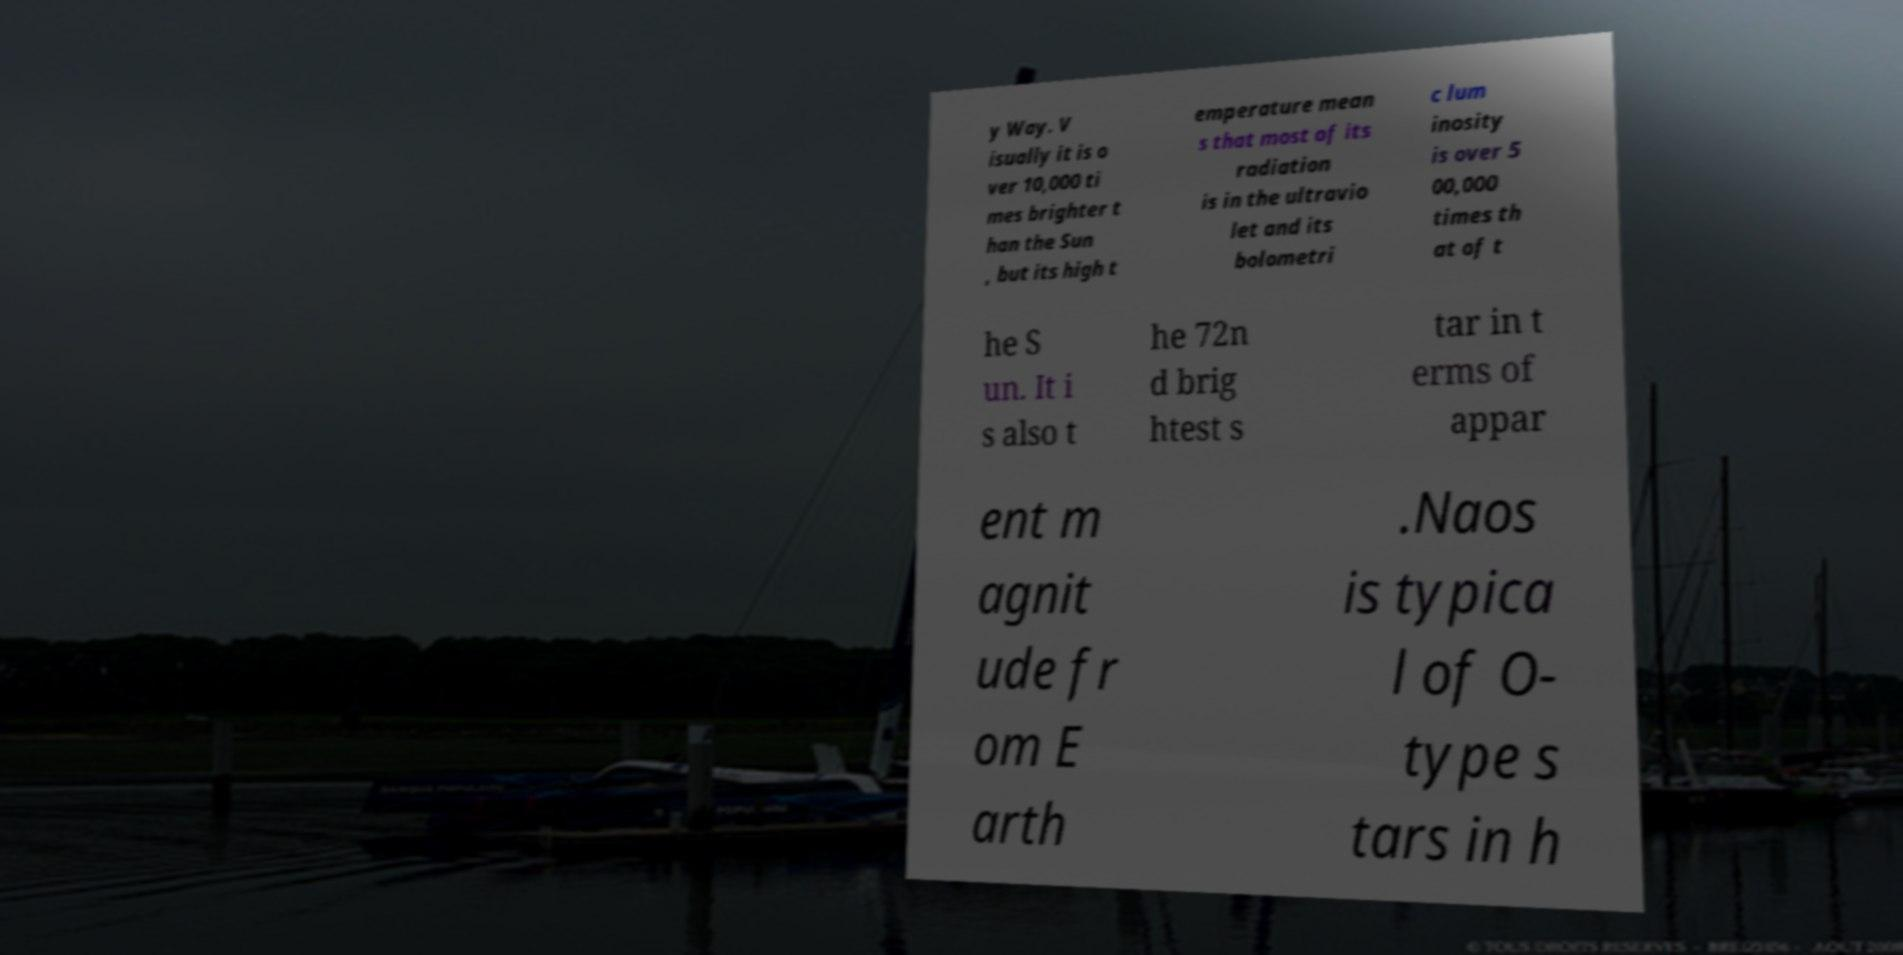Please identify and transcribe the text found in this image. y Way. V isually it is o ver 10,000 ti mes brighter t han the Sun , but its high t emperature mean s that most of its radiation is in the ultravio let and its bolometri c lum inosity is over 5 00,000 times th at of t he S un. It i s also t he 72n d brig htest s tar in t erms of appar ent m agnit ude fr om E arth .Naos is typica l of O- type s tars in h 